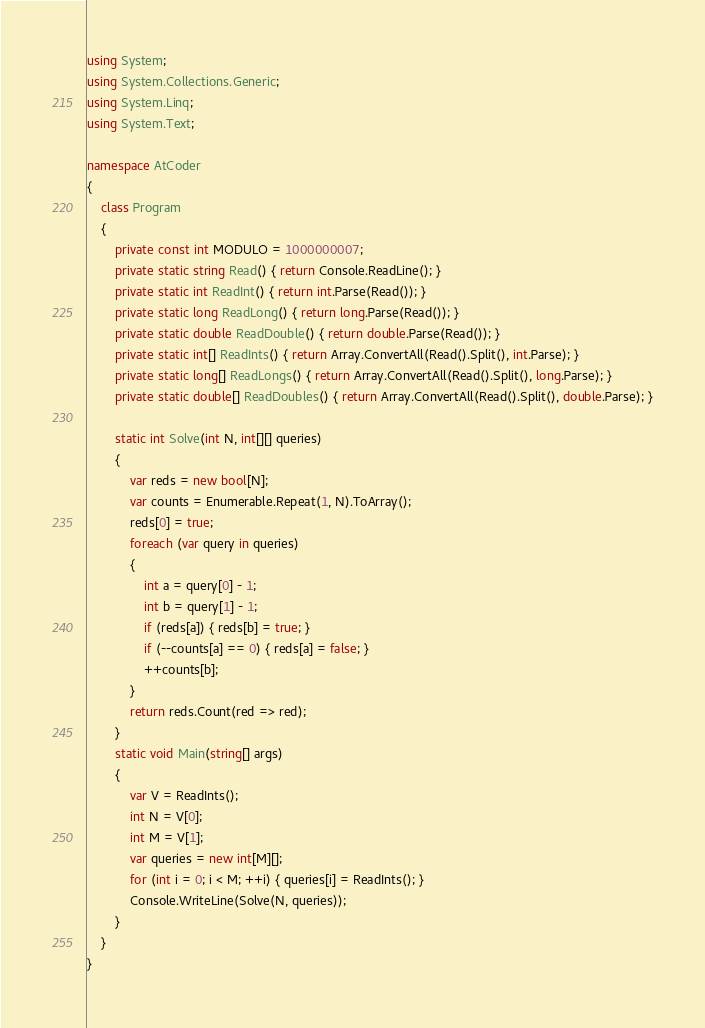<code> <loc_0><loc_0><loc_500><loc_500><_C#_>using System;
using System.Collections.Generic;
using System.Linq;
using System.Text;

namespace AtCoder
{
    class Program
    {
        private const int MODULO = 1000000007;
        private static string Read() { return Console.ReadLine(); }
        private static int ReadInt() { return int.Parse(Read()); }
        private static long ReadLong() { return long.Parse(Read()); }
        private static double ReadDouble() { return double.Parse(Read()); }
        private static int[] ReadInts() { return Array.ConvertAll(Read().Split(), int.Parse); }
        private static long[] ReadLongs() { return Array.ConvertAll(Read().Split(), long.Parse); }
        private static double[] ReadDoubles() { return Array.ConvertAll(Read().Split(), double.Parse); }

        static int Solve(int N, int[][] queries)
        {
            var reds = new bool[N];
            var counts = Enumerable.Repeat(1, N).ToArray();
            reds[0] = true;
            foreach (var query in queries)
            {
                int a = query[0] - 1;
                int b = query[1] - 1;
                if (reds[a]) { reds[b] = true; }
                if (--counts[a] == 0) { reds[a] = false; }
                ++counts[b];
            }
            return reds.Count(red => red);
        }
        static void Main(string[] args)
        {
            var V = ReadInts();
            int N = V[0];
            int M = V[1];
            var queries = new int[M][];
            for (int i = 0; i < M; ++i) { queries[i] = ReadInts(); }
            Console.WriteLine(Solve(N, queries));
        }
    }
}
</code> 